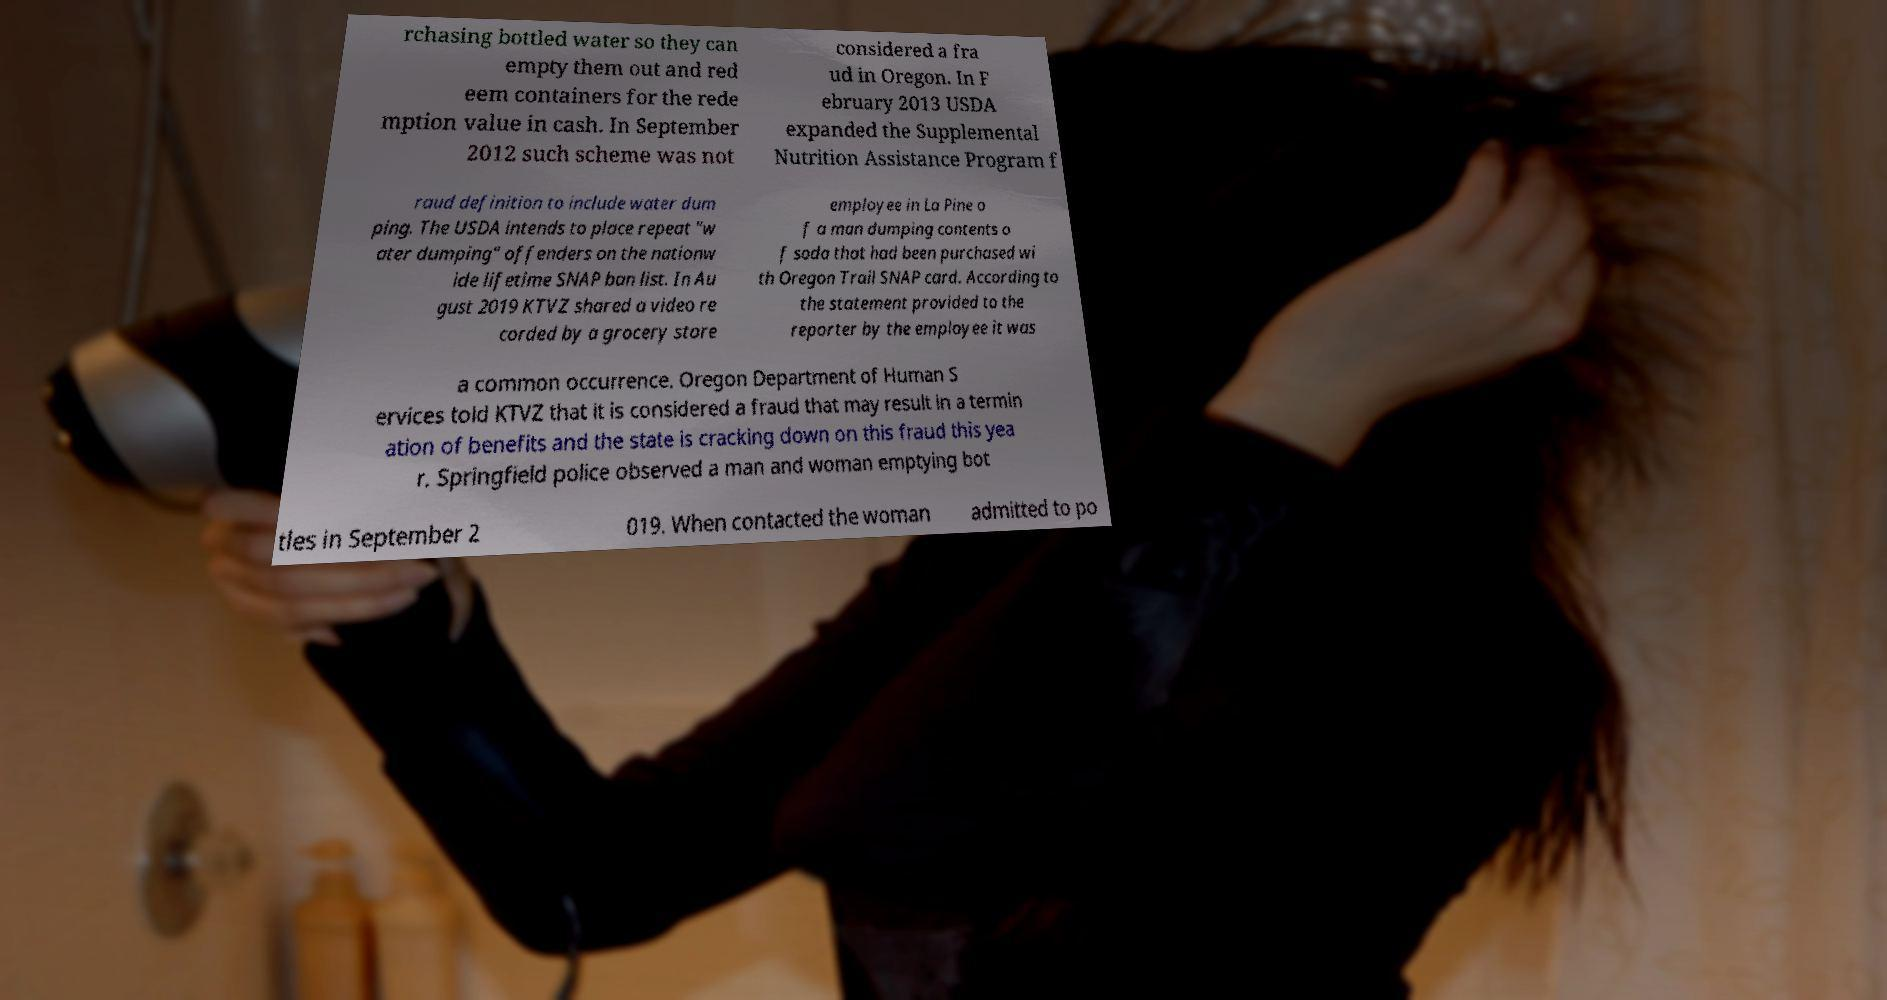Please identify and transcribe the text found in this image. rchasing bottled water so they can empty them out and red eem containers for the rede mption value in cash. In September 2012 such scheme was not considered a fra ud in Oregon. In F ebruary 2013 USDA expanded the Supplemental Nutrition Assistance Program f raud definition to include water dum ping. The USDA intends to place repeat "w ater dumping" offenders on the nationw ide lifetime SNAP ban list. In Au gust 2019 KTVZ shared a video re corded by a grocery store employee in La Pine o f a man dumping contents o f soda that had been purchased wi th Oregon Trail SNAP card. According to the statement provided to the reporter by the employee it was a common occurrence. Oregon Department of Human S ervices told KTVZ that it is considered a fraud that may result in a termin ation of benefits and the state is cracking down on this fraud this yea r. Springfield police observed a man and woman emptying bot tles in September 2 019. When contacted the woman admitted to po 